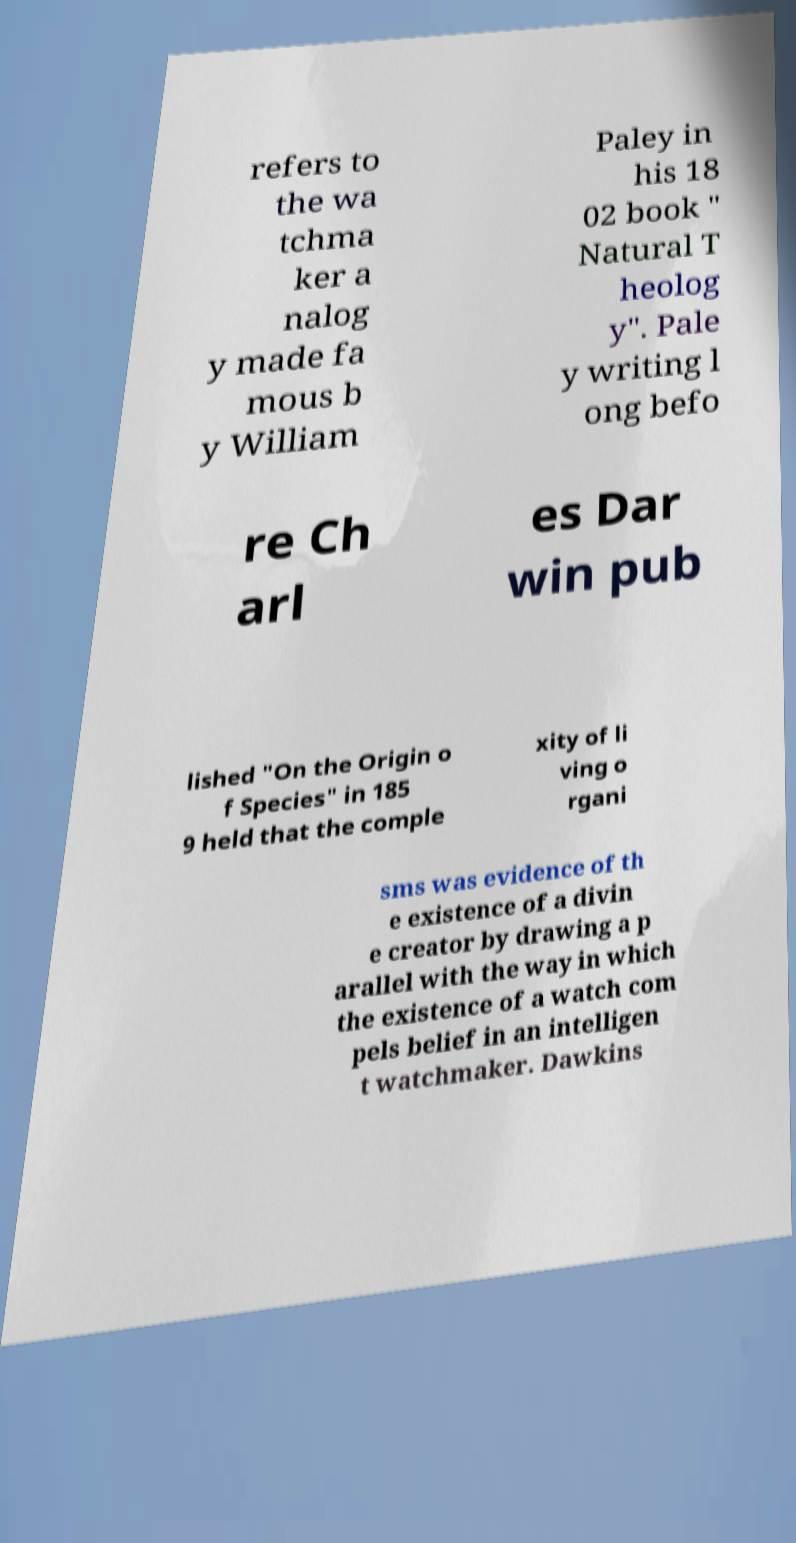Please read and relay the text visible in this image. What does it say? refers to the wa tchma ker a nalog y made fa mous b y William Paley in his 18 02 book " Natural T heolog y". Pale y writing l ong befo re Ch arl es Dar win pub lished "On the Origin o f Species" in 185 9 held that the comple xity of li ving o rgani sms was evidence of th e existence of a divin e creator by drawing a p arallel with the way in which the existence of a watch com pels belief in an intelligen t watchmaker. Dawkins 